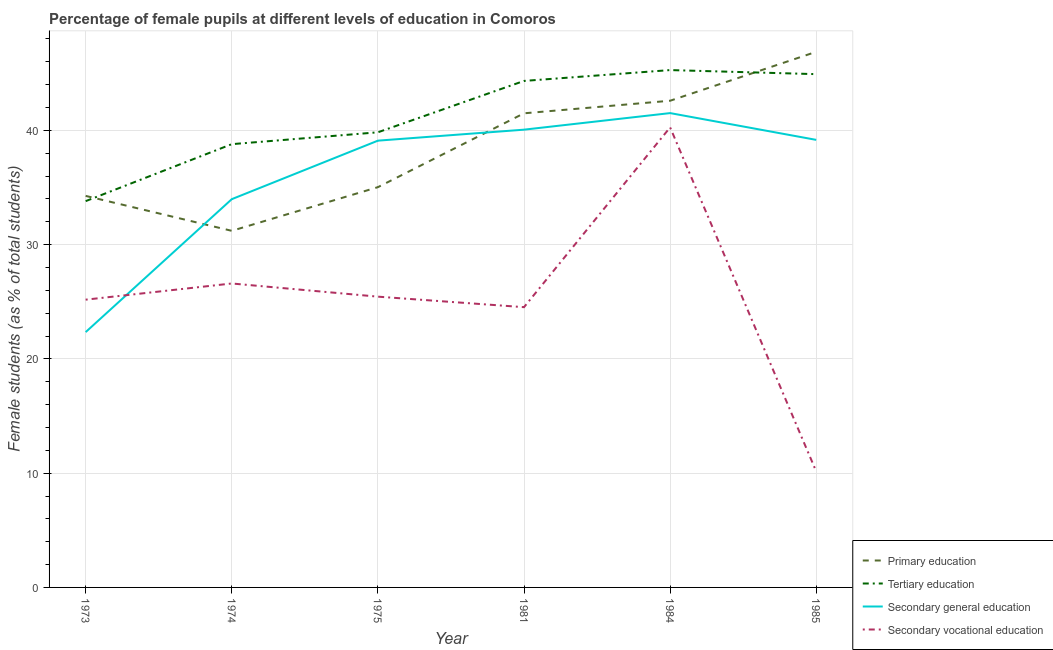Does the line corresponding to percentage of female students in primary education intersect with the line corresponding to percentage of female students in secondary vocational education?
Provide a short and direct response. No. Is the number of lines equal to the number of legend labels?
Make the answer very short. Yes. What is the percentage of female students in tertiary education in 1973?
Keep it short and to the point. 33.81. Across all years, what is the maximum percentage of female students in tertiary education?
Offer a terse response. 45.28. Across all years, what is the minimum percentage of female students in secondary education?
Ensure brevity in your answer.  22.35. In which year was the percentage of female students in tertiary education minimum?
Give a very brief answer. 1973. What is the total percentage of female students in tertiary education in the graph?
Provide a short and direct response. 246.97. What is the difference between the percentage of female students in primary education in 1974 and that in 1981?
Make the answer very short. -10.29. What is the difference between the percentage of female students in primary education in 1984 and the percentage of female students in secondary education in 1975?
Your response must be concise. 3.49. What is the average percentage of female students in tertiary education per year?
Your answer should be compact. 41.16. In the year 1985, what is the difference between the percentage of female students in primary education and percentage of female students in secondary vocational education?
Your answer should be compact. 36.73. What is the ratio of the percentage of female students in secondary education in 1974 to that in 1984?
Offer a terse response. 0.82. Is the percentage of female students in secondary vocational education in 1973 less than that in 1984?
Provide a short and direct response. Yes. What is the difference between the highest and the second highest percentage of female students in primary education?
Provide a short and direct response. 4.28. What is the difference between the highest and the lowest percentage of female students in secondary education?
Provide a short and direct response. 19.17. In how many years, is the percentage of female students in secondary education greater than the average percentage of female students in secondary education taken over all years?
Provide a succinct answer. 4. Is the sum of the percentage of female students in secondary vocational education in 1974 and 1981 greater than the maximum percentage of female students in secondary education across all years?
Offer a terse response. Yes. Is it the case that in every year, the sum of the percentage of female students in primary education and percentage of female students in secondary vocational education is greater than the sum of percentage of female students in secondary education and percentage of female students in tertiary education?
Your response must be concise. No. Is the percentage of female students in tertiary education strictly greater than the percentage of female students in secondary vocational education over the years?
Ensure brevity in your answer.  Yes. How many years are there in the graph?
Ensure brevity in your answer.  6. Does the graph contain any zero values?
Ensure brevity in your answer.  No. Does the graph contain grids?
Give a very brief answer. Yes. Where does the legend appear in the graph?
Offer a very short reply. Bottom right. How many legend labels are there?
Your answer should be compact. 4. What is the title of the graph?
Make the answer very short. Percentage of female pupils at different levels of education in Comoros. Does "Secondary schools" appear as one of the legend labels in the graph?
Offer a very short reply. No. What is the label or title of the Y-axis?
Your answer should be compact. Female students (as % of total students). What is the Female students (as % of total students) of Primary education in 1973?
Provide a short and direct response. 34.27. What is the Female students (as % of total students) of Tertiary education in 1973?
Your answer should be very brief. 33.81. What is the Female students (as % of total students) in Secondary general education in 1973?
Ensure brevity in your answer.  22.35. What is the Female students (as % of total students) of Secondary vocational education in 1973?
Your answer should be compact. 25.19. What is the Female students (as % of total students) of Primary education in 1974?
Your answer should be very brief. 31.21. What is the Female students (as % of total students) in Tertiary education in 1974?
Your response must be concise. 38.8. What is the Female students (as % of total students) of Secondary general education in 1974?
Give a very brief answer. 33.98. What is the Female students (as % of total students) of Secondary vocational education in 1974?
Provide a succinct answer. 26.6. What is the Female students (as % of total students) in Primary education in 1975?
Your response must be concise. 35.03. What is the Female students (as % of total students) of Tertiary education in 1975?
Give a very brief answer. 39.83. What is the Female students (as % of total students) of Secondary general education in 1975?
Offer a very short reply. 39.1. What is the Female students (as % of total students) of Secondary vocational education in 1975?
Keep it short and to the point. 25.45. What is the Female students (as % of total students) of Primary education in 1981?
Provide a short and direct response. 41.5. What is the Female students (as % of total students) of Tertiary education in 1981?
Make the answer very short. 44.33. What is the Female students (as % of total students) of Secondary general education in 1981?
Provide a short and direct response. 40.06. What is the Female students (as % of total students) of Secondary vocational education in 1981?
Offer a terse response. 24.53. What is the Female students (as % of total students) of Primary education in 1984?
Offer a terse response. 42.6. What is the Female students (as % of total students) in Tertiary education in 1984?
Give a very brief answer. 45.28. What is the Female students (as % of total students) in Secondary general education in 1984?
Keep it short and to the point. 41.51. What is the Female students (as % of total students) in Secondary vocational education in 1984?
Your answer should be compact. 40.27. What is the Female students (as % of total students) of Primary education in 1985?
Give a very brief answer. 46.88. What is the Female students (as % of total students) of Tertiary education in 1985?
Ensure brevity in your answer.  44.92. What is the Female students (as % of total students) in Secondary general education in 1985?
Give a very brief answer. 39.17. What is the Female students (as % of total students) in Secondary vocational education in 1985?
Make the answer very short. 10.14. Across all years, what is the maximum Female students (as % of total students) of Primary education?
Your answer should be very brief. 46.88. Across all years, what is the maximum Female students (as % of total students) of Tertiary education?
Provide a short and direct response. 45.28. Across all years, what is the maximum Female students (as % of total students) in Secondary general education?
Offer a terse response. 41.51. Across all years, what is the maximum Female students (as % of total students) in Secondary vocational education?
Your answer should be very brief. 40.27. Across all years, what is the minimum Female students (as % of total students) of Primary education?
Keep it short and to the point. 31.21. Across all years, what is the minimum Female students (as % of total students) of Tertiary education?
Offer a very short reply. 33.81. Across all years, what is the minimum Female students (as % of total students) of Secondary general education?
Give a very brief answer. 22.35. Across all years, what is the minimum Female students (as % of total students) in Secondary vocational education?
Offer a terse response. 10.14. What is the total Female students (as % of total students) of Primary education in the graph?
Provide a short and direct response. 231.48. What is the total Female students (as % of total students) of Tertiary education in the graph?
Provide a succinct answer. 246.97. What is the total Female students (as % of total students) in Secondary general education in the graph?
Your response must be concise. 216.18. What is the total Female students (as % of total students) of Secondary vocational education in the graph?
Offer a very short reply. 152.18. What is the difference between the Female students (as % of total students) of Primary education in 1973 and that in 1974?
Offer a very short reply. 3.06. What is the difference between the Female students (as % of total students) in Tertiary education in 1973 and that in 1974?
Provide a succinct answer. -4.99. What is the difference between the Female students (as % of total students) of Secondary general education in 1973 and that in 1974?
Your response must be concise. -11.64. What is the difference between the Female students (as % of total students) of Secondary vocational education in 1973 and that in 1974?
Your answer should be very brief. -1.42. What is the difference between the Female students (as % of total students) in Primary education in 1973 and that in 1975?
Offer a very short reply. -0.76. What is the difference between the Female students (as % of total students) in Tertiary education in 1973 and that in 1975?
Provide a short and direct response. -6.02. What is the difference between the Female students (as % of total students) in Secondary general education in 1973 and that in 1975?
Your response must be concise. -16.76. What is the difference between the Female students (as % of total students) in Secondary vocational education in 1973 and that in 1975?
Offer a terse response. -0.26. What is the difference between the Female students (as % of total students) of Primary education in 1973 and that in 1981?
Make the answer very short. -7.23. What is the difference between the Female students (as % of total students) in Tertiary education in 1973 and that in 1981?
Your answer should be compact. -10.52. What is the difference between the Female students (as % of total students) in Secondary general education in 1973 and that in 1981?
Offer a terse response. -17.72. What is the difference between the Female students (as % of total students) in Secondary vocational education in 1973 and that in 1981?
Offer a very short reply. 0.66. What is the difference between the Female students (as % of total students) of Primary education in 1973 and that in 1984?
Keep it short and to the point. -8.33. What is the difference between the Female students (as % of total students) in Tertiary education in 1973 and that in 1984?
Keep it short and to the point. -11.47. What is the difference between the Female students (as % of total students) of Secondary general education in 1973 and that in 1984?
Your answer should be compact. -19.17. What is the difference between the Female students (as % of total students) of Secondary vocational education in 1973 and that in 1984?
Your answer should be very brief. -15.08. What is the difference between the Female students (as % of total students) in Primary education in 1973 and that in 1985?
Keep it short and to the point. -12.61. What is the difference between the Female students (as % of total students) in Tertiary education in 1973 and that in 1985?
Keep it short and to the point. -11.11. What is the difference between the Female students (as % of total students) of Secondary general education in 1973 and that in 1985?
Make the answer very short. -16.82. What is the difference between the Female students (as % of total students) in Secondary vocational education in 1973 and that in 1985?
Give a very brief answer. 15.04. What is the difference between the Female students (as % of total students) in Primary education in 1974 and that in 1975?
Keep it short and to the point. -3.82. What is the difference between the Female students (as % of total students) of Tertiary education in 1974 and that in 1975?
Make the answer very short. -1.04. What is the difference between the Female students (as % of total students) in Secondary general education in 1974 and that in 1975?
Provide a short and direct response. -5.12. What is the difference between the Female students (as % of total students) of Secondary vocational education in 1974 and that in 1975?
Offer a terse response. 1.15. What is the difference between the Female students (as % of total students) of Primary education in 1974 and that in 1981?
Your answer should be compact. -10.29. What is the difference between the Female students (as % of total students) of Tertiary education in 1974 and that in 1981?
Your answer should be compact. -5.53. What is the difference between the Female students (as % of total students) of Secondary general education in 1974 and that in 1981?
Ensure brevity in your answer.  -6.08. What is the difference between the Female students (as % of total students) in Secondary vocational education in 1974 and that in 1981?
Provide a succinct answer. 2.07. What is the difference between the Female students (as % of total students) of Primary education in 1974 and that in 1984?
Your answer should be compact. -11.39. What is the difference between the Female students (as % of total students) of Tertiary education in 1974 and that in 1984?
Give a very brief answer. -6.48. What is the difference between the Female students (as % of total students) of Secondary general education in 1974 and that in 1984?
Keep it short and to the point. -7.53. What is the difference between the Female students (as % of total students) in Secondary vocational education in 1974 and that in 1984?
Your response must be concise. -13.66. What is the difference between the Female students (as % of total students) in Primary education in 1974 and that in 1985?
Provide a short and direct response. -15.67. What is the difference between the Female students (as % of total students) of Tertiary education in 1974 and that in 1985?
Your response must be concise. -6.13. What is the difference between the Female students (as % of total students) of Secondary general education in 1974 and that in 1985?
Provide a succinct answer. -5.19. What is the difference between the Female students (as % of total students) in Secondary vocational education in 1974 and that in 1985?
Make the answer very short. 16.46. What is the difference between the Female students (as % of total students) in Primary education in 1975 and that in 1981?
Make the answer very short. -6.46. What is the difference between the Female students (as % of total students) in Tertiary education in 1975 and that in 1981?
Your answer should be very brief. -4.5. What is the difference between the Female students (as % of total students) of Secondary general education in 1975 and that in 1981?
Offer a very short reply. -0.96. What is the difference between the Female students (as % of total students) of Secondary vocational education in 1975 and that in 1981?
Make the answer very short. 0.92. What is the difference between the Female students (as % of total students) of Primary education in 1975 and that in 1984?
Ensure brevity in your answer.  -7.56. What is the difference between the Female students (as % of total students) of Tertiary education in 1975 and that in 1984?
Your response must be concise. -5.45. What is the difference between the Female students (as % of total students) in Secondary general education in 1975 and that in 1984?
Offer a very short reply. -2.41. What is the difference between the Female students (as % of total students) in Secondary vocational education in 1975 and that in 1984?
Your answer should be very brief. -14.82. What is the difference between the Female students (as % of total students) of Primary education in 1975 and that in 1985?
Provide a short and direct response. -11.85. What is the difference between the Female students (as % of total students) of Tertiary education in 1975 and that in 1985?
Your response must be concise. -5.09. What is the difference between the Female students (as % of total students) of Secondary general education in 1975 and that in 1985?
Your answer should be very brief. -0.07. What is the difference between the Female students (as % of total students) of Secondary vocational education in 1975 and that in 1985?
Provide a succinct answer. 15.3. What is the difference between the Female students (as % of total students) in Primary education in 1981 and that in 1984?
Ensure brevity in your answer.  -1.1. What is the difference between the Female students (as % of total students) of Tertiary education in 1981 and that in 1984?
Your response must be concise. -0.95. What is the difference between the Female students (as % of total students) of Secondary general education in 1981 and that in 1984?
Ensure brevity in your answer.  -1.45. What is the difference between the Female students (as % of total students) in Secondary vocational education in 1981 and that in 1984?
Offer a very short reply. -15.74. What is the difference between the Female students (as % of total students) in Primary education in 1981 and that in 1985?
Provide a short and direct response. -5.38. What is the difference between the Female students (as % of total students) of Tertiary education in 1981 and that in 1985?
Your answer should be compact. -0.59. What is the difference between the Female students (as % of total students) of Secondary general education in 1981 and that in 1985?
Provide a succinct answer. 0.89. What is the difference between the Female students (as % of total students) in Secondary vocational education in 1981 and that in 1985?
Ensure brevity in your answer.  14.38. What is the difference between the Female students (as % of total students) of Primary education in 1984 and that in 1985?
Make the answer very short. -4.28. What is the difference between the Female students (as % of total students) of Tertiary education in 1984 and that in 1985?
Ensure brevity in your answer.  0.36. What is the difference between the Female students (as % of total students) of Secondary general education in 1984 and that in 1985?
Ensure brevity in your answer.  2.34. What is the difference between the Female students (as % of total students) of Secondary vocational education in 1984 and that in 1985?
Your response must be concise. 30.12. What is the difference between the Female students (as % of total students) in Primary education in 1973 and the Female students (as % of total students) in Tertiary education in 1974?
Make the answer very short. -4.53. What is the difference between the Female students (as % of total students) of Primary education in 1973 and the Female students (as % of total students) of Secondary general education in 1974?
Give a very brief answer. 0.29. What is the difference between the Female students (as % of total students) in Primary education in 1973 and the Female students (as % of total students) in Secondary vocational education in 1974?
Keep it short and to the point. 7.67. What is the difference between the Female students (as % of total students) in Tertiary education in 1973 and the Female students (as % of total students) in Secondary general education in 1974?
Make the answer very short. -0.17. What is the difference between the Female students (as % of total students) in Tertiary education in 1973 and the Female students (as % of total students) in Secondary vocational education in 1974?
Make the answer very short. 7.21. What is the difference between the Female students (as % of total students) in Secondary general education in 1973 and the Female students (as % of total students) in Secondary vocational education in 1974?
Ensure brevity in your answer.  -4.26. What is the difference between the Female students (as % of total students) in Primary education in 1973 and the Female students (as % of total students) in Tertiary education in 1975?
Your answer should be very brief. -5.57. What is the difference between the Female students (as % of total students) in Primary education in 1973 and the Female students (as % of total students) in Secondary general education in 1975?
Your answer should be compact. -4.83. What is the difference between the Female students (as % of total students) of Primary education in 1973 and the Female students (as % of total students) of Secondary vocational education in 1975?
Offer a terse response. 8.82. What is the difference between the Female students (as % of total students) of Tertiary education in 1973 and the Female students (as % of total students) of Secondary general education in 1975?
Ensure brevity in your answer.  -5.29. What is the difference between the Female students (as % of total students) in Tertiary education in 1973 and the Female students (as % of total students) in Secondary vocational education in 1975?
Your answer should be very brief. 8.36. What is the difference between the Female students (as % of total students) in Secondary general education in 1973 and the Female students (as % of total students) in Secondary vocational education in 1975?
Give a very brief answer. -3.1. What is the difference between the Female students (as % of total students) in Primary education in 1973 and the Female students (as % of total students) in Tertiary education in 1981?
Keep it short and to the point. -10.06. What is the difference between the Female students (as % of total students) of Primary education in 1973 and the Female students (as % of total students) of Secondary general education in 1981?
Provide a succinct answer. -5.8. What is the difference between the Female students (as % of total students) of Primary education in 1973 and the Female students (as % of total students) of Secondary vocational education in 1981?
Ensure brevity in your answer.  9.74. What is the difference between the Female students (as % of total students) in Tertiary education in 1973 and the Female students (as % of total students) in Secondary general education in 1981?
Keep it short and to the point. -6.26. What is the difference between the Female students (as % of total students) in Tertiary education in 1973 and the Female students (as % of total students) in Secondary vocational education in 1981?
Make the answer very short. 9.28. What is the difference between the Female students (as % of total students) of Secondary general education in 1973 and the Female students (as % of total students) of Secondary vocational education in 1981?
Your response must be concise. -2.18. What is the difference between the Female students (as % of total students) of Primary education in 1973 and the Female students (as % of total students) of Tertiary education in 1984?
Make the answer very short. -11.01. What is the difference between the Female students (as % of total students) in Primary education in 1973 and the Female students (as % of total students) in Secondary general education in 1984?
Make the answer very short. -7.25. What is the difference between the Female students (as % of total students) of Primary education in 1973 and the Female students (as % of total students) of Secondary vocational education in 1984?
Your answer should be compact. -6. What is the difference between the Female students (as % of total students) of Tertiary education in 1973 and the Female students (as % of total students) of Secondary general education in 1984?
Your answer should be very brief. -7.71. What is the difference between the Female students (as % of total students) in Tertiary education in 1973 and the Female students (as % of total students) in Secondary vocational education in 1984?
Your response must be concise. -6.46. What is the difference between the Female students (as % of total students) in Secondary general education in 1973 and the Female students (as % of total students) in Secondary vocational education in 1984?
Your answer should be compact. -17.92. What is the difference between the Female students (as % of total students) in Primary education in 1973 and the Female students (as % of total students) in Tertiary education in 1985?
Give a very brief answer. -10.66. What is the difference between the Female students (as % of total students) of Primary education in 1973 and the Female students (as % of total students) of Secondary general education in 1985?
Provide a short and direct response. -4.9. What is the difference between the Female students (as % of total students) of Primary education in 1973 and the Female students (as % of total students) of Secondary vocational education in 1985?
Your response must be concise. 24.12. What is the difference between the Female students (as % of total students) in Tertiary education in 1973 and the Female students (as % of total students) in Secondary general education in 1985?
Your response must be concise. -5.36. What is the difference between the Female students (as % of total students) in Tertiary education in 1973 and the Female students (as % of total students) in Secondary vocational education in 1985?
Ensure brevity in your answer.  23.66. What is the difference between the Female students (as % of total students) in Secondary general education in 1973 and the Female students (as % of total students) in Secondary vocational education in 1985?
Ensure brevity in your answer.  12.2. What is the difference between the Female students (as % of total students) in Primary education in 1974 and the Female students (as % of total students) in Tertiary education in 1975?
Provide a short and direct response. -8.62. What is the difference between the Female students (as % of total students) in Primary education in 1974 and the Female students (as % of total students) in Secondary general education in 1975?
Provide a succinct answer. -7.89. What is the difference between the Female students (as % of total students) in Primary education in 1974 and the Female students (as % of total students) in Secondary vocational education in 1975?
Make the answer very short. 5.76. What is the difference between the Female students (as % of total students) of Tertiary education in 1974 and the Female students (as % of total students) of Secondary general education in 1975?
Keep it short and to the point. -0.31. What is the difference between the Female students (as % of total students) of Tertiary education in 1974 and the Female students (as % of total students) of Secondary vocational education in 1975?
Your answer should be very brief. 13.35. What is the difference between the Female students (as % of total students) in Secondary general education in 1974 and the Female students (as % of total students) in Secondary vocational education in 1975?
Provide a short and direct response. 8.53. What is the difference between the Female students (as % of total students) of Primary education in 1974 and the Female students (as % of total students) of Tertiary education in 1981?
Make the answer very short. -13.12. What is the difference between the Female students (as % of total students) of Primary education in 1974 and the Female students (as % of total students) of Secondary general education in 1981?
Your answer should be very brief. -8.85. What is the difference between the Female students (as % of total students) in Primary education in 1974 and the Female students (as % of total students) in Secondary vocational education in 1981?
Your answer should be very brief. 6.68. What is the difference between the Female students (as % of total students) in Tertiary education in 1974 and the Female students (as % of total students) in Secondary general education in 1981?
Provide a short and direct response. -1.27. What is the difference between the Female students (as % of total students) in Tertiary education in 1974 and the Female students (as % of total students) in Secondary vocational education in 1981?
Provide a short and direct response. 14.27. What is the difference between the Female students (as % of total students) of Secondary general education in 1974 and the Female students (as % of total students) of Secondary vocational education in 1981?
Give a very brief answer. 9.45. What is the difference between the Female students (as % of total students) in Primary education in 1974 and the Female students (as % of total students) in Tertiary education in 1984?
Your answer should be very brief. -14.07. What is the difference between the Female students (as % of total students) in Primary education in 1974 and the Female students (as % of total students) in Secondary general education in 1984?
Your answer should be very brief. -10.3. What is the difference between the Female students (as % of total students) of Primary education in 1974 and the Female students (as % of total students) of Secondary vocational education in 1984?
Offer a very short reply. -9.05. What is the difference between the Female students (as % of total students) of Tertiary education in 1974 and the Female students (as % of total students) of Secondary general education in 1984?
Offer a terse response. -2.72. What is the difference between the Female students (as % of total students) of Tertiary education in 1974 and the Female students (as % of total students) of Secondary vocational education in 1984?
Provide a succinct answer. -1.47. What is the difference between the Female students (as % of total students) of Secondary general education in 1974 and the Female students (as % of total students) of Secondary vocational education in 1984?
Provide a short and direct response. -6.28. What is the difference between the Female students (as % of total students) in Primary education in 1974 and the Female students (as % of total students) in Tertiary education in 1985?
Offer a terse response. -13.71. What is the difference between the Female students (as % of total students) of Primary education in 1974 and the Female students (as % of total students) of Secondary general education in 1985?
Provide a short and direct response. -7.96. What is the difference between the Female students (as % of total students) of Primary education in 1974 and the Female students (as % of total students) of Secondary vocational education in 1985?
Offer a terse response. 21.07. What is the difference between the Female students (as % of total students) of Tertiary education in 1974 and the Female students (as % of total students) of Secondary general education in 1985?
Make the answer very short. -0.37. What is the difference between the Female students (as % of total students) in Tertiary education in 1974 and the Female students (as % of total students) in Secondary vocational education in 1985?
Your answer should be very brief. 28.65. What is the difference between the Female students (as % of total students) in Secondary general education in 1974 and the Female students (as % of total students) in Secondary vocational education in 1985?
Offer a very short reply. 23.84. What is the difference between the Female students (as % of total students) in Primary education in 1975 and the Female students (as % of total students) in Tertiary education in 1981?
Your response must be concise. -9.3. What is the difference between the Female students (as % of total students) of Primary education in 1975 and the Female students (as % of total students) of Secondary general education in 1981?
Your response must be concise. -5.03. What is the difference between the Female students (as % of total students) in Primary education in 1975 and the Female students (as % of total students) in Secondary vocational education in 1981?
Offer a terse response. 10.5. What is the difference between the Female students (as % of total students) in Tertiary education in 1975 and the Female students (as % of total students) in Secondary general education in 1981?
Provide a succinct answer. -0.23. What is the difference between the Female students (as % of total students) of Tertiary education in 1975 and the Female students (as % of total students) of Secondary vocational education in 1981?
Your response must be concise. 15.31. What is the difference between the Female students (as % of total students) of Secondary general education in 1975 and the Female students (as % of total students) of Secondary vocational education in 1981?
Your response must be concise. 14.57. What is the difference between the Female students (as % of total students) of Primary education in 1975 and the Female students (as % of total students) of Tertiary education in 1984?
Ensure brevity in your answer.  -10.25. What is the difference between the Female students (as % of total students) of Primary education in 1975 and the Female students (as % of total students) of Secondary general education in 1984?
Ensure brevity in your answer.  -6.48. What is the difference between the Female students (as % of total students) in Primary education in 1975 and the Female students (as % of total students) in Secondary vocational education in 1984?
Make the answer very short. -5.23. What is the difference between the Female students (as % of total students) in Tertiary education in 1975 and the Female students (as % of total students) in Secondary general education in 1984?
Your answer should be compact. -1.68. What is the difference between the Female students (as % of total students) of Tertiary education in 1975 and the Female students (as % of total students) of Secondary vocational education in 1984?
Offer a terse response. -0.43. What is the difference between the Female students (as % of total students) in Secondary general education in 1975 and the Female students (as % of total students) in Secondary vocational education in 1984?
Ensure brevity in your answer.  -1.16. What is the difference between the Female students (as % of total students) in Primary education in 1975 and the Female students (as % of total students) in Tertiary education in 1985?
Give a very brief answer. -9.89. What is the difference between the Female students (as % of total students) of Primary education in 1975 and the Female students (as % of total students) of Secondary general education in 1985?
Offer a very short reply. -4.14. What is the difference between the Female students (as % of total students) in Primary education in 1975 and the Female students (as % of total students) in Secondary vocational education in 1985?
Offer a very short reply. 24.89. What is the difference between the Female students (as % of total students) in Tertiary education in 1975 and the Female students (as % of total students) in Secondary general education in 1985?
Give a very brief answer. 0.66. What is the difference between the Female students (as % of total students) of Tertiary education in 1975 and the Female students (as % of total students) of Secondary vocational education in 1985?
Provide a short and direct response. 29.69. What is the difference between the Female students (as % of total students) of Secondary general education in 1975 and the Female students (as % of total students) of Secondary vocational education in 1985?
Give a very brief answer. 28.96. What is the difference between the Female students (as % of total students) in Primary education in 1981 and the Female students (as % of total students) in Tertiary education in 1984?
Provide a succinct answer. -3.78. What is the difference between the Female students (as % of total students) in Primary education in 1981 and the Female students (as % of total students) in Secondary general education in 1984?
Your response must be concise. -0.02. What is the difference between the Female students (as % of total students) in Primary education in 1981 and the Female students (as % of total students) in Secondary vocational education in 1984?
Offer a very short reply. 1.23. What is the difference between the Female students (as % of total students) in Tertiary education in 1981 and the Female students (as % of total students) in Secondary general education in 1984?
Provide a short and direct response. 2.82. What is the difference between the Female students (as % of total students) of Tertiary education in 1981 and the Female students (as % of total students) of Secondary vocational education in 1984?
Your answer should be very brief. 4.07. What is the difference between the Female students (as % of total students) in Secondary general education in 1981 and the Female students (as % of total students) in Secondary vocational education in 1984?
Your answer should be very brief. -0.2. What is the difference between the Female students (as % of total students) of Primary education in 1981 and the Female students (as % of total students) of Tertiary education in 1985?
Keep it short and to the point. -3.43. What is the difference between the Female students (as % of total students) of Primary education in 1981 and the Female students (as % of total students) of Secondary general education in 1985?
Your answer should be compact. 2.33. What is the difference between the Female students (as % of total students) of Primary education in 1981 and the Female students (as % of total students) of Secondary vocational education in 1985?
Make the answer very short. 31.35. What is the difference between the Female students (as % of total students) of Tertiary education in 1981 and the Female students (as % of total students) of Secondary general education in 1985?
Make the answer very short. 5.16. What is the difference between the Female students (as % of total students) of Tertiary education in 1981 and the Female students (as % of total students) of Secondary vocational education in 1985?
Provide a short and direct response. 34.19. What is the difference between the Female students (as % of total students) of Secondary general education in 1981 and the Female students (as % of total students) of Secondary vocational education in 1985?
Your answer should be very brief. 29.92. What is the difference between the Female students (as % of total students) in Primary education in 1984 and the Female students (as % of total students) in Tertiary education in 1985?
Provide a short and direct response. -2.33. What is the difference between the Female students (as % of total students) of Primary education in 1984 and the Female students (as % of total students) of Secondary general education in 1985?
Provide a succinct answer. 3.43. What is the difference between the Female students (as % of total students) of Primary education in 1984 and the Female students (as % of total students) of Secondary vocational education in 1985?
Ensure brevity in your answer.  32.45. What is the difference between the Female students (as % of total students) of Tertiary education in 1984 and the Female students (as % of total students) of Secondary general education in 1985?
Provide a short and direct response. 6.11. What is the difference between the Female students (as % of total students) in Tertiary education in 1984 and the Female students (as % of total students) in Secondary vocational education in 1985?
Provide a succinct answer. 35.13. What is the difference between the Female students (as % of total students) of Secondary general education in 1984 and the Female students (as % of total students) of Secondary vocational education in 1985?
Ensure brevity in your answer.  31.37. What is the average Female students (as % of total students) in Primary education per year?
Your response must be concise. 38.58. What is the average Female students (as % of total students) of Tertiary education per year?
Give a very brief answer. 41.16. What is the average Female students (as % of total students) in Secondary general education per year?
Your answer should be very brief. 36.03. What is the average Female students (as % of total students) of Secondary vocational education per year?
Your answer should be compact. 25.36. In the year 1973, what is the difference between the Female students (as % of total students) in Primary education and Female students (as % of total students) in Tertiary education?
Offer a very short reply. 0.46. In the year 1973, what is the difference between the Female students (as % of total students) in Primary education and Female students (as % of total students) in Secondary general education?
Provide a succinct answer. 11.92. In the year 1973, what is the difference between the Female students (as % of total students) in Primary education and Female students (as % of total students) in Secondary vocational education?
Give a very brief answer. 9.08. In the year 1973, what is the difference between the Female students (as % of total students) in Tertiary education and Female students (as % of total students) in Secondary general education?
Your answer should be very brief. 11.46. In the year 1973, what is the difference between the Female students (as % of total students) in Tertiary education and Female students (as % of total students) in Secondary vocational education?
Provide a short and direct response. 8.62. In the year 1973, what is the difference between the Female students (as % of total students) of Secondary general education and Female students (as % of total students) of Secondary vocational education?
Keep it short and to the point. -2.84. In the year 1974, what is the difference between the Female students (as % of total students) in Primary education and Female students (as % of total students) in Tertiary education?
Offer a very short reply. -7.59. In the year 1974, what is the difference between the Female students (as % of total students) in Primary education and Female students (as % of total students) in Secondary general education?
Keep it short and to the point. -2.77. In the year 1974, what is the difference between the Female students (as % of total students) of Primary education and Female students (as % of total students) of Secondary vocational education?
Your answer should be compact. 4.61. In the year 1974, what is the difference between the Female students (as % of total students) of Tertiary education and Female students (as % of total students) of Secondary general education?
Offer a very short reply. 4.82. In the year 1974, what is the difference between the Female students (as % of total students) in Tertiary education and Female students (as % of total students) in Secondary vocational education?
Make the answer very short. 12.19. In the year 1974, what is the difference between the Female students (as % of total students) in Secondary general education and Female students (as % of total students) in Secondary vocational education?
Offer a very short reply. 7.38. In the year 1975, what is the difference between the Female students (as % of total students) in Primary education and Female students (as % of total students) in Tertiary education?
Give a very brief answer. -4.8. In the year 1975, what is the difference between the Female students (as % of total students) in Primary education and Female students (as % of total students) in Secondary general education?
Give a very brief answer. -4.07. In the year 1975, what is the difference between the Female students (as % of total students) in Primary education and Female students (as % of total students) in Secondary vocational education?
Your answer should be compact. 9.58. In the year 1975, what is the difference between the Female students (as % of total students) in Tertiary education and Female students (as % of total students) in Secondary general education?
Keep it short and to the point. 0.73. In the year 1975, what is the difference between the Female students (as % of total students) of Tertiary education and Female students (as % of total students) of Secondary vocational education?
Your response must be concise. 14.38. In the year 1975, what is the difference between the Female students (as % of total students) in Secondary general education and Female students (as % of total students) in Secondary vocational education?
Give a very brief answer. 13.65. In the year 1981, what is the difference between the Female students (as % of total students) in Primary education and Female students (as % of total students) in Tertiary education?
Offer a very short reply. -2.83. In the year 1981, what is the difference between the Female students (as % of total students) of Primary education and Female students (as % of total students) of Secondary general education?
Your response must be concise. 1.43. In the year 1981, what is the difference between the Female students (as % of total students) in Primary education and Female students (as % of total students) in Secondary vocational education?
Your response must be concise. 16.97. In the year 1981, what is the difference between the Female students (as % of total students) in Tertiary education and Female students (as % of total students) in Secondary general education?
Offer a very short reply. 4.27. In the year 1981, what is the difference between the Female students (as % of total students) in Tertiary education and Female students (as % of total students) in Secondary vocational education?
Your answer should be compact. 19.8. In the year 1981, what is the difference between the Female students (as % of total students) in Secondary general education and Female students (as % of total students) in Secondary vocational education?
Provide a short and direct response. 15.54. In the year 1984, what is the difference between the Female students (as % of total students) in Primary education and Female students (as % of total students) in Tertiary education?
Your response must be concise. -2.68. In the year 1984, what is the difference between the Female students (as % of total students) of Primary education and Female students (as % of total students) of Secondary general education?
Your response must be concise. 1.08. In the year 1984, what is the difference between the Female students (as % of total students) in Primary education and Female students (as % of total students) in Secondary vocational education?
Make the answer very short. 2.33. In the year 1984, what is the difference between the Female students (as % of total students) in Tertiary education and Female students (as % of total students) in Secondary general education?
Offer a terse response. 3.76. In the year 1984, what is the difference between the Female students (as % of total students) in Tertiary education and Female students (as % of total students) in Secondary vocational education?
Your response must be concise. 5.01. In the year 1984, what is the difference between the Female students (as % of total students) in Secondary general education and Female students (as % of total students) in Secondary vocational education?
Ensure brevity in your answer.  1.25. In the year 1985, what is the difference between the Female students (as % of total students) in Primary education and Female students (as % of total students) in Tertiary education?
Give a very brief answer. 1.96. In the year 1985, what is the difference between the Female students (as % of total students) of Primary education and Female students (as % of total students) of Secondary general education?
Provide a short and direct response. 7.71. In the year 1985, what is the difference between the Female students (as % of total students) of Primary education and Female students (as % of total students) of Secondary vocational education?
Your response must be concise. 36.73. In the year 1985, what is the difference between the Female students (as % of total students) in Tertiary education and Female students (as % of total students) in Secondary general education?
Provide a short and direct response. 5.75. In the year 1985, what is the difference between the Female students (as % of total students) of Tertiary education and Female students (as % of total students) of Secondary vocational education?
Offer a terse response. 34.78. In the year 1985, what is the difference between the Female students (as % of total students) in Secondary general education and Female students (as % of total students) in Secondary vocational education?
Offer a terse response. 29.03. What is the ratio of the Female students (as % of total students) in Primary education in 1973 to that in 1974?
Make the answer very short. 1.1. What is the ratio of the Female students (as % of total students) in Tertiary education in 1973 to that in 1974?
Your response must be concise. 0.87. What is the ratio of the Female students (as % of total students) in Secondary general education in 1973 to that in 1974?
Ensure brevity in your answer.  0.66. What is the ratio of the Female students (as % of total students) of Secondary vocational education in 1973 to that in 1974?
Make the answer very short. 0.95. What is the ratio of the Female students (as % of total students) in Primary education in 1973 to that in 1975?
Your answer should be very brief. 0.98. What is the ratio of the Female students (as % of total students) of Tertiary education in 1973 to that in 1975?
Provide a short and direct response. 0.85. What is the ratio of the Female students (as % of total students) in Secondary general education in 1973 to that in 1975?
Keep it short and to the point. 0.57. What is the ratio of the Female students (as % of total students) in Secondary vocational education in 1973 to that in 1975?
Your answer should be compact. 0.99. What is the ratio of the Female students (as % of total students) of Primary education in 1973 to that in 1981?
Provide a short and direct response. 0.83. What is the ratio of the Female students (as % of total students) in Tertiary education in 1973 to that in 1981?
Offer a very short reply. 0.76. What is the ratio of the Female students (as % of total students) of Secondary general education in 1973 to that in 1981?
Give a very brief answer. 0.56. What is the ratio of the Female students (as % of total students) in Secondary vocational education in 1973 to that in 1981?
Keep it short and to the point. 1.03. What is the ratio of the Female students (as % of total students) of Primary education in 1973 to that in 1984?
Provide a succinct answer. 0.8. What is the ratio of the Female students (as % of total students) in Tertiary education in 1973 to that in 1984?
Make the answer very short. 0.75. What is the ratio of the Female students (as % of total students) in Secondary general education in 1973 to that in 1984?
Give a very brief answer. 0.54. What is the ratio of the Female students (as % of total students) in Secondary vocational education in 1973 to that in 1984?
Make the answer very short. 0.63. What is the ratio of the Female students (as % of total students) of Primary education in 1973 to that in 1985?
Offer a very short reply. 0.73. What is the ratio of the Female students (as % of total students) in Tertiary education in 1973 to that in 1985?
Offer a terse response. 0.75. What is the ratio of the Female students (as % of total students) in Secondary general education in 1973 to that in 1985?
Offer a terse response. 0.57. What is the ratio of the Female students (as % of total students) of Secondary vocational education in 1973 to that in 1985?
Ensure brevity in your answer.  2.48. What is the ratio of the Female students (as % of total students) of Primary education in 1974 to that in 1975?
Offer a very short reply. 0.89. What is the ratio of the Female students (as % of total students) of Secondary general education in 1974 to that in 1975?
Offer a terse response. 0.87. What is the ratio of the Female students (as % of total students) of Secondary vocational education in 1974 to that in 1975?
Make the answer very short. 1.05. What is the ratio of the Female students (as % of total students) of Primary education in 1974 to that in 1981?
Ensure brevity in your answer.  0.75. What is the ratio of the Female students (as % of total students) of Tertiary education in 1974 to that in 1981?
Your answer should be very brief. 0.88. What is the ratio of the Female students (as % of total students) in Secondary general education in 1974 to that in 1981?
Provide a succinct answer. 0.85. What is the ratio of the Female students (as % of total students) in Secondary vocational education in 1974 to that in 1981?
Your answer should be very brief. 1.08. What is the ratio of the Female students (as % of total students) of Primary education in 1974 to that in 1984?
Offer a terse response. 0.73. What is the ratio of the Female students (as % of total students) of Tertiary education in 1974 to that in 1984?
Your response must be concise. 0.86. What is the ratio of the Female students (as % of total students) in Secondary general education in 1974 to that in 1984?
Provide a short and direct response. 0.82. What is the ratio of the Female students (as % of total students) in Secondary vocational education in 1974 to that in 1984?
Make the answer very short. 0.66. What is the ratio of the Female students (as % of total students) in Primary education in 1974 to that in 1985?
Your answer should be compact. 0.67. What is the ratio of the Female students (as % of total students) in Tertiary education in 1974 to that in 1985?
Give a very brief answer. 0.86. What is the ratio of the Female students (as % of total students) of Secondary general education in 1974 to that in 1985?
Your answer should be very brief. 0.87. What is the ratio of the Female students (as % of total students) of Secondary vocational education in 1974 to that in 1985?
Provide a succinct answer. 2.62. What is the ratio of the Female students (as % of total students) in Primary education in 1975 to that in 1981?
Your answer should be very brief. 0.84. What is the ratio of the Female students (as % of total students) of Tertiary education in 1975 to that in 1981?
Your response must be concise. 0.9. What is the ratio of the Female students (as % of total students) in Secondary general education in 1975 to that in 1981?
Your response must be concise. 0.98. What is the ratio of the Female students (as % of total students) of Secondary vocational education in 1975 to that in 1981?
Give a very brief answer. 1.04. What is the ratio of the Female students (as % of total students) of Primary education in 1975 to that in 1984?
Offer a terse response. 0.82. What is the ratio of the Female students (as % of total students) in Tertiary education in 1975 to that in 1984?
Offer a very short reply. 0.88. What is the ratio of the Female students (as % of total students) in Secondary general education in 1975 to that in 1984?
Your response must be concise. 0.94. What is the ratio of the Female students (as % of total students) in Secondary vocational education in 1975 to that in 1984?
Provide a succinct answer. 0.63. What is the ratio of the Female students (as % of total students) in Primary education in 1975 to that in 1985?
Make the answer very short. 0.75. What is the ratio of the Female students (as % of total students) in Tertiary education in 1975 to that in 1985?
Give a very brief answer. 0.89. What is the ratio of the Female students (as % of total students) of Secondary general education in 1975 to that in 1985?
Your answer should be compact. 1. What is the ratio of the Female students (as % of total students) of Secondary vocational education in 1975 to that in 1985?
Your response must be concise. 2.51. What is the ratio of the Female students (as % of total students) in Primary education in 1981 to that in 1984?
Make the answer very short. 0.97. What is the ratio of the Female students (as % of total students) in Tertiary education in 1981 to that in 1984?
Your answer should be very brief. 0.98. What is the ratio of the Female students (as % of total students) of Secondary general education in 1981 to that in 1984?
Ensure brevity in your answer.  0.97. What is the ratio of the Female students (as % of total students) of Secondary vocational education in 1981 to that in 1984?
Your response must be concise. 0.61. What is the ratio of the Female students (as % of total students) in Primary education in 1981 to that in 1985?
Offer a very short reply. 0.89. What is the ratio of the Female students (as % of total students) of Tertiary education in 1981 to that in 1985?
Offer a very short reply. 0.99. What is the ratio of the Female students (as % of total students) of Secondary general education in 1981 to that in 1985?
Keep it short and to the point. 1.02. What is the ratio of the Female students (as % of total students) in Secondary vocational education in 1981 to that in 1985?
Your answer should be very brief. 2.42. What is the ratio of the Female students (as % of total students) in Primary education in 1984 to that in 1985?
Provide a succinct answer. 0.91. What is the ratio of the Female students (as % of total students) in Tertiary education in 1984 to that in 1985?
Give a very brief answer. 1.01. What is the ratio of the Female students (as % of total students) of Secondary general education in 1984 to that in 1985?
Make the answer very short. 1.06. What is the ratio of the Female students (as % of total students) in Secondary vocational education in 1984 to that in 1985?
Offer a very short reply. 3.97. What is the difference between the highest and the second highest Female students (as % of total students) of Primary education?
Offer a terse response. 4.28. What is the difference between the highest and the second highest Female students (as % of total students) of Tertiary education?
Offer a terse response. 0.36. What is the difference between the highest and the second highest Female students (as % of total students) of Secondary general education?
Offer a terse response. 1.45. What is the difference between the highest and the second highest Female students (as % of total students) of Secondary vocational education?
Your response must be concise. 13.66. What is the difference between the highest and the lowest Female students (as % of total students) of Primary education?
Your answer should be compact. 15.67. What is the difference between the highest and the lowest Female students (as % of total students) in Tertiary education?
Offer a very short reply. 11.47. What is the difference between the highest and the lowest Female students (as % of total students) in Secondary general education?
Ensure brevity in your answer.  19.17. What is the difference between the highest and the lowest Female students (as % of total students) in Secondary vocational education?
Your answer should be very brief. 30.12. 